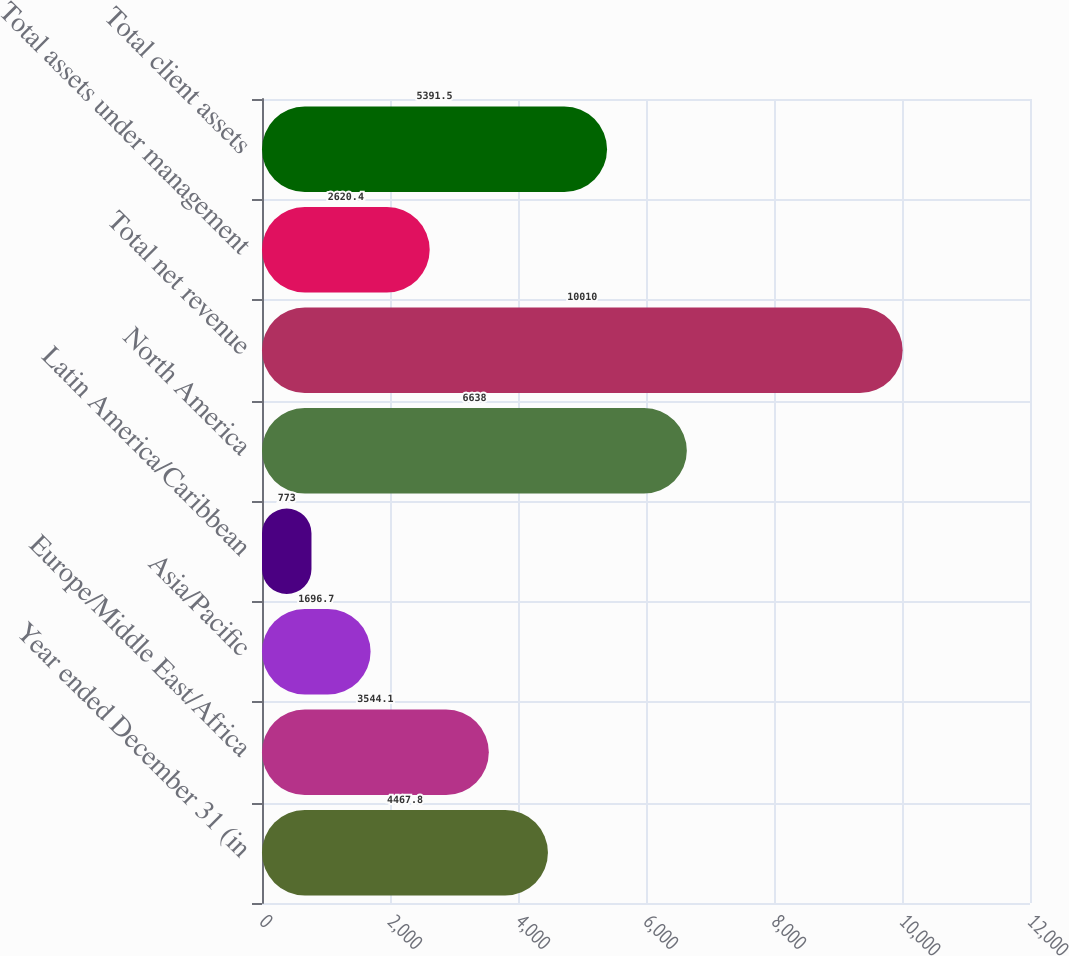Convert chart. <chart><loc_0><loc_0><loc_500><loc_500><bar_chart><fcel>Year ended December 31 (in<fcel>Europe/Middle East/Africa<fcel>Asia/Pacific<fcel>Latin America/Caribbean<fcel>North America<fcel>Total net revenue<fcel>Total assets under management<fcel>Total client assets<nl><fcel>4467.8<fcel>3544.1<fcel>1696.7<fcel>773<fcel>6638<fcel>10010<fcel>2620.4<fcel>5391.5<nl></chart> 